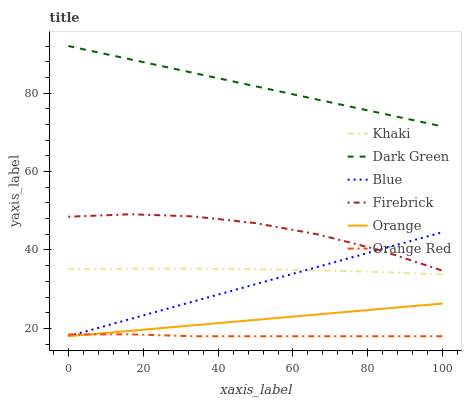Does Khaki have the minimum area under the curve?
Answer yes or no. No. Does Khaki have the maximum area under the curve?
Answer yes or no. No. Is Khaki the smoothest?
Answer yes or no. No. Is Khaki the roughest?
Answer yes or no. No. Does Khaki have the lowest value?
Answer yes or no. No. Does Khaki have the highest value?
Answer yes or no. No. Is Orange less than Firebrick?
Answer yes or no. Yes. Is Dark Green greater than Khaki?
Answer yes or no. Yes. Does Orange intersect Firebrick?
Answer yes or no. No. 